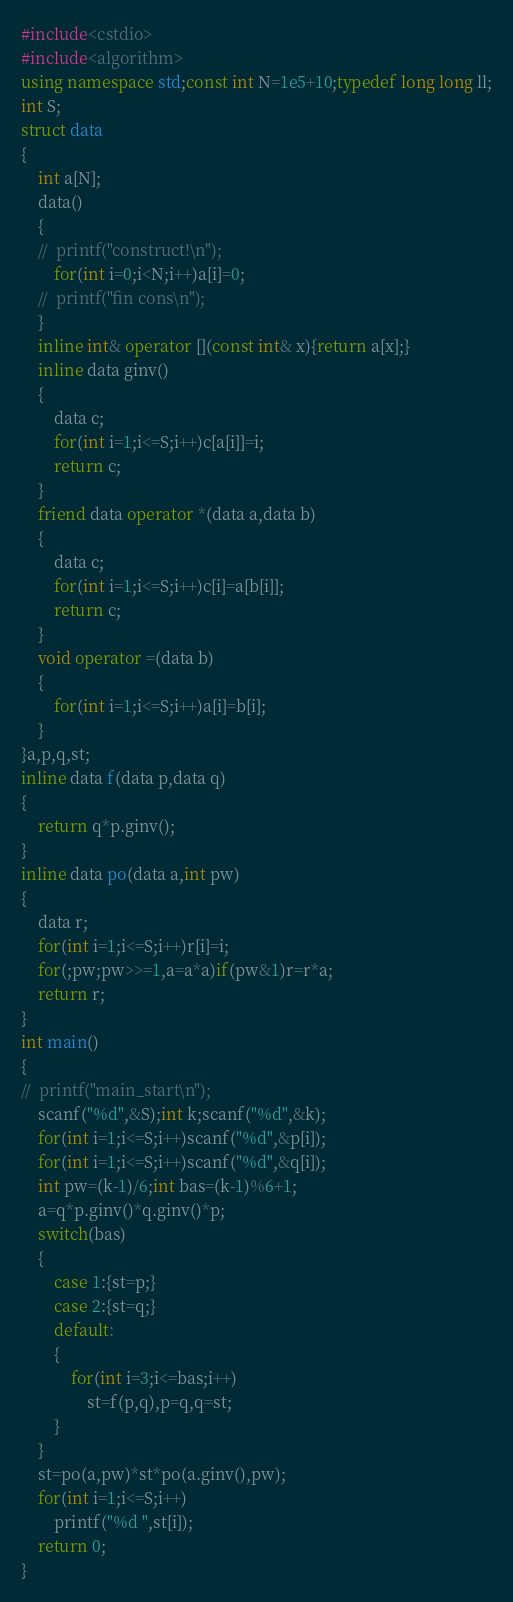Convert code to text. <code><loc_0><loc_0><loc_500><loc_500><_C++_>#include<cstdio>
#include<algorithm>
using namespace std;const int N=1e5+10;typedef long long ll;
int S;
struct data
{
	int a[N];
	data()
	{
	//	printf("construct!\n");
		for(int i=0;i<N;i++)a[i]=0;
	//	printf("fin cons\n");
	}
	inline int& operator [](const int& x){return a[x];}
	inline data ginv()
	{
		data c;
		for(int i=1;i<=S;i++)c[a[i]]=i;
		return c;
	} 
	friend data operator *(data a,data b)
	{
		data c;
		for(int i=1;i<=S;i++)c[i]=a[b[i]];
		return c;
	}
	void operator =(data b)
	{
		for(int i=1;i<=S;i++)a[i]=b[i];
	}
}a,p,q,st;
inline data f(data p,data q)
{
	return q*p.ginv();
}
inline data po(data a,int pw)
{
	data r;
	for(int i=1;i<=S;i++)r[i]=i;
	for(;pw;pw>>=1,a=a*a)if(pw&1)r=r*a;
	return r;
}
int main()
{
//	printf("main_start\n");
	scanf("%d",&S);int k;scanf("%d",&k);
	for(int i=1;i<=S;i++)scanf("%d",&p[i]);
	for(int i=1;i<=S;i++)scanf("%d",&q[i]);
	int pw=(k-1)/6;int bas=(k-1)%6+1;
	a=q*p.ginv()*q.ginv()*p;
	switch(bas)
	{
		case 1:{st=p;}
		case 2:{st=q;}
		default:
		{
			for(int i=3;i<=bas;i++)
				st=f(p,q),p=q,q=st;
		}
	}
	st=po(a,pw)*st*po(a.ginv(),pw);
	for(int i=1;i<=S;i++)
		printf("%d ",st[i]);
	return 0;
}</code> 